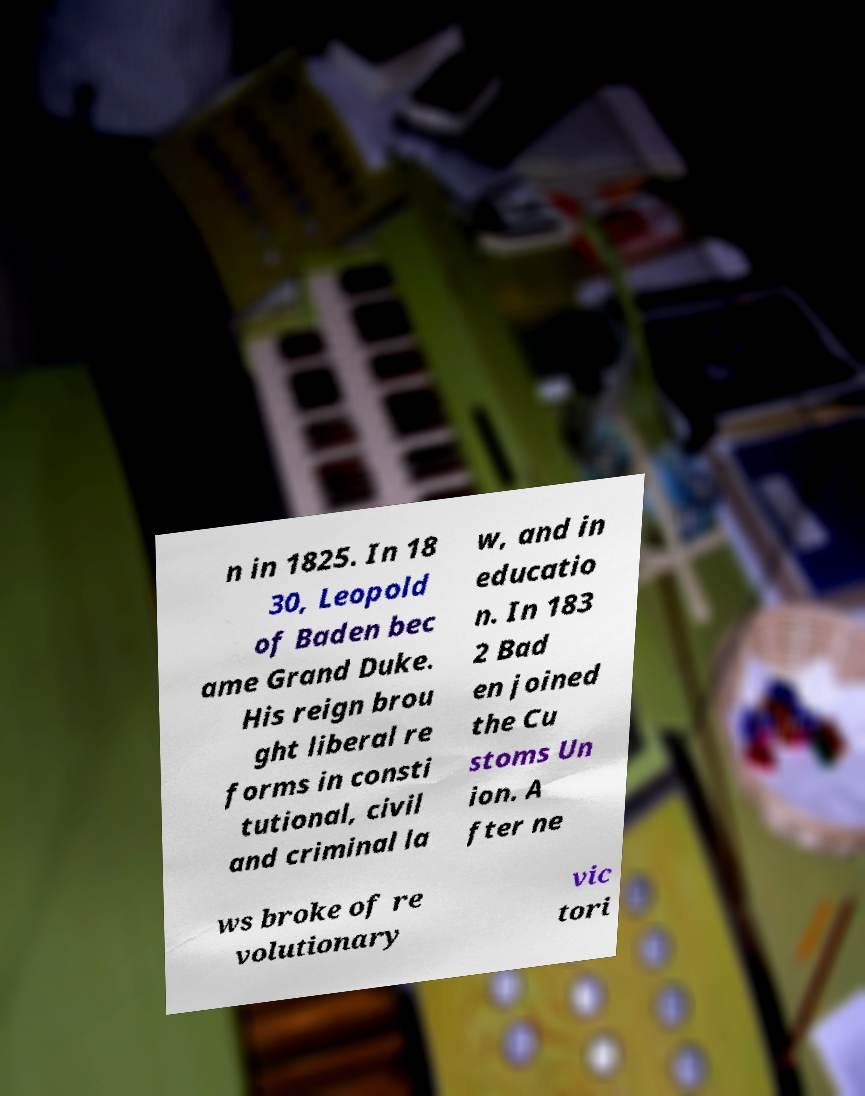Please identify and transcribe the text found in this image. n in 1825. In 18 30, Leopold of Baden bec ame Grand Duke. His reign brou ght liberal re forms in consti tutional, civil and criminal la w, and in educatio n. In 183 2 Bad en joined the Cu stoms Un ion. A fter ne ws broke of re volutionary vic tori 